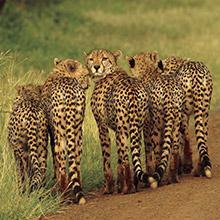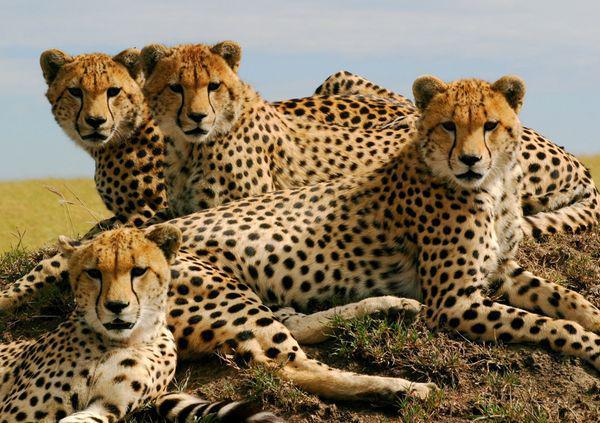The first image is the image on the left, the second image is the image on the right. Assess this claim about the two images: "the right image has three cheetas". Correct or not? Answer yes or no. No. The first image is the image on the left, the second image is the image on the right. For the images displayed, is the sentence "In the image on the right, there are no cheetahs - instead we have leopards, with broader faces, and larger spots, without the black tear duct path the cheetahs have." factually correct? Answer yes or no. No. 